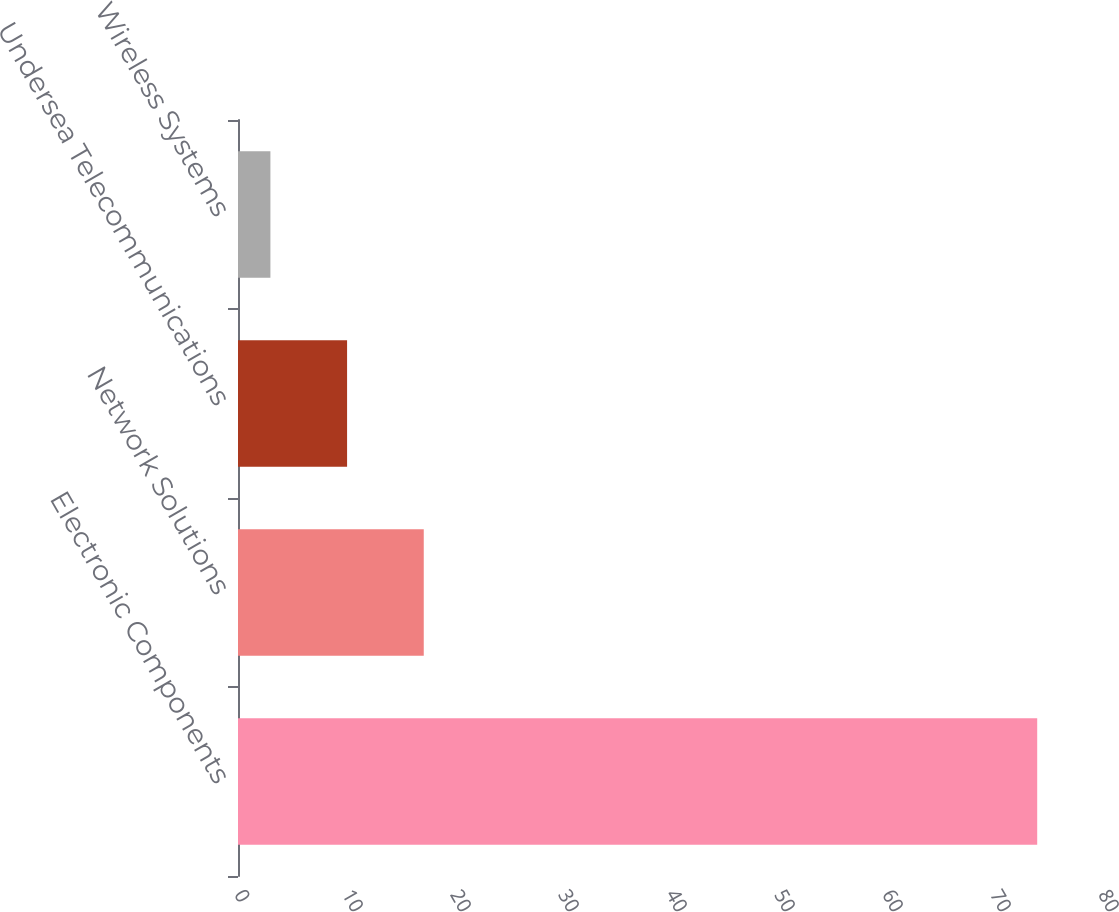<chart> <loc_0><loc_0><loc_500><loc_500><bar_chart><fcel>Electronic Components<fcel>Network Solutions<fcel>Undersea Telecommunications<fcel>Wireless Systems<nl><fcel>74<fcel>17.2<fcel>10.1<fcel>3<nl></chart> 